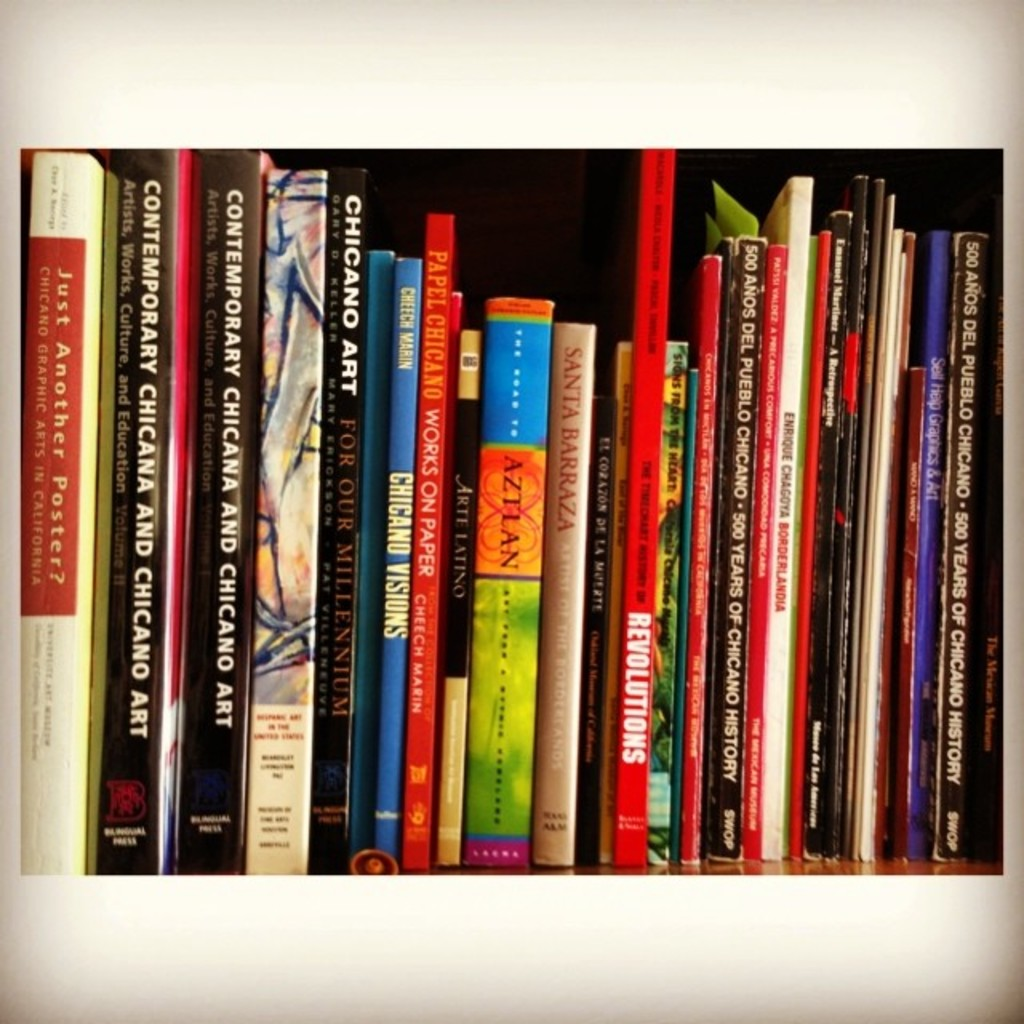Can you spot any book that might be considered rare or unusually interesting on this shelf? The book 'Just Another Poster? Chicano Graphic Arts in California' seems particularly intriguing, suggesting a specialized focus on Chicano visual culture and graphic arts, which might be a rare topic depending on the context and geographical focus of the collection. 